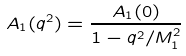<formula> <loc_0><loc_0><loc_500><loc_500>A _ { 1 } ( q ^ { 2 } ) = \frac { A _ { 1 } ( 0 ) } { 1 - q ^ { 2 } / M _ { 1 } ^ { 2 } }</formula> 